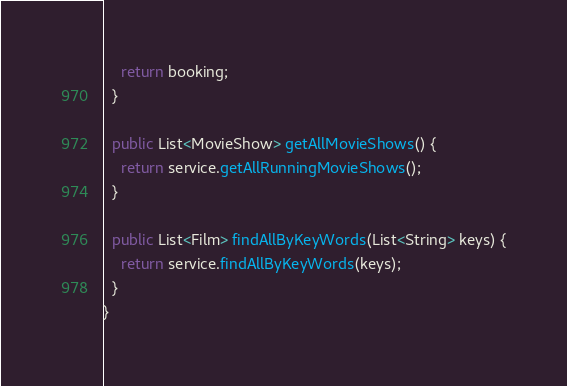<code> <loc_0><loc_0><loc_500><loc_500><_Java_>    return booking;
  }

  public List<MovieShow> getAllMovieShows() {
    return service.getAllRunningMovieShows();
  }

  public List<Film> findAllByKeyWords(List<String> keys) {
    return service.findAllByKeyWords(keys);
  }
}
</code> 